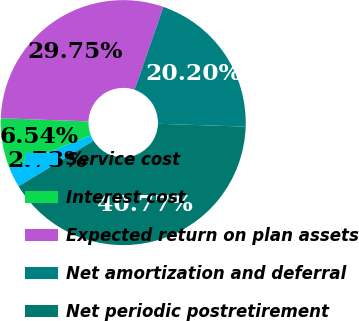Convert chart. <chart><loc_0><loc_0><loc_500><loc_500><pie_chart><fcel>Service cost<fcel>Interest cost<fcel>Expected return on plan assets<fcel>Net amortization and deferral<fcel>Net periodic postretirement<nl><fcel>2.73%<fcel>6.54%<fcel>29.75%<fcel>20.2%<fcel>40.77%<nl></chart> 